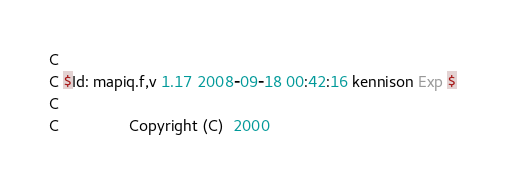Convert code to text. <code><loc_0><loc_0><loc_500><loc_500><_FORTRAN_>C
C $Id: mapiq.f,v 1.17 2008-09-18 00:42:16 kennison Exp $
C
C                Copyright (C)  2000</code> 